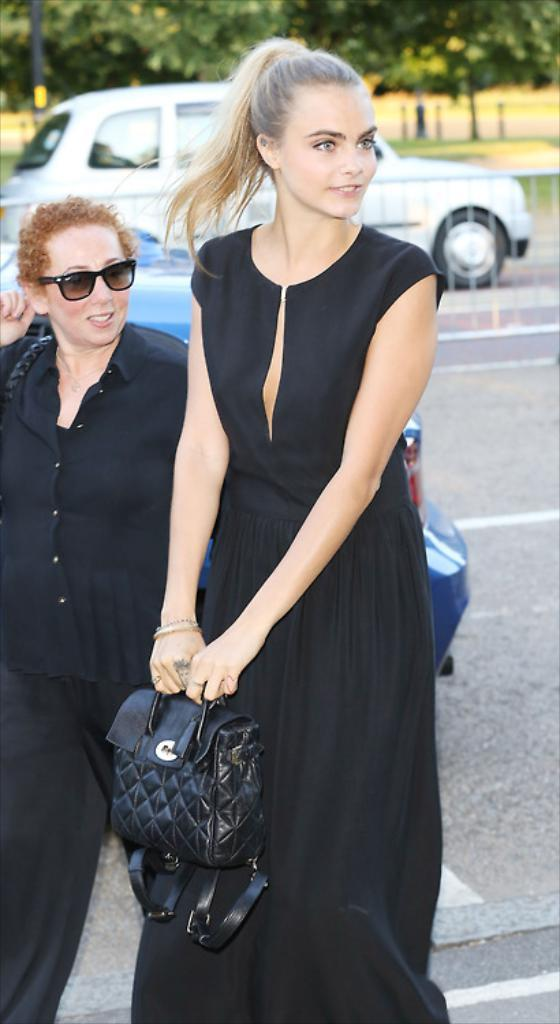How many people are in the image? There are two people in the image. What color are the dresses worn by the people? Both people are wearing black color dresses. What is the lady holding in the image? The lady is holding a black bag. What can be seen in the background of the image? There is a car and trees around the people. What type of desk is visible in the image? There is no desk present in the image. What year is depicted in the image? The image does not depict a specific year. 